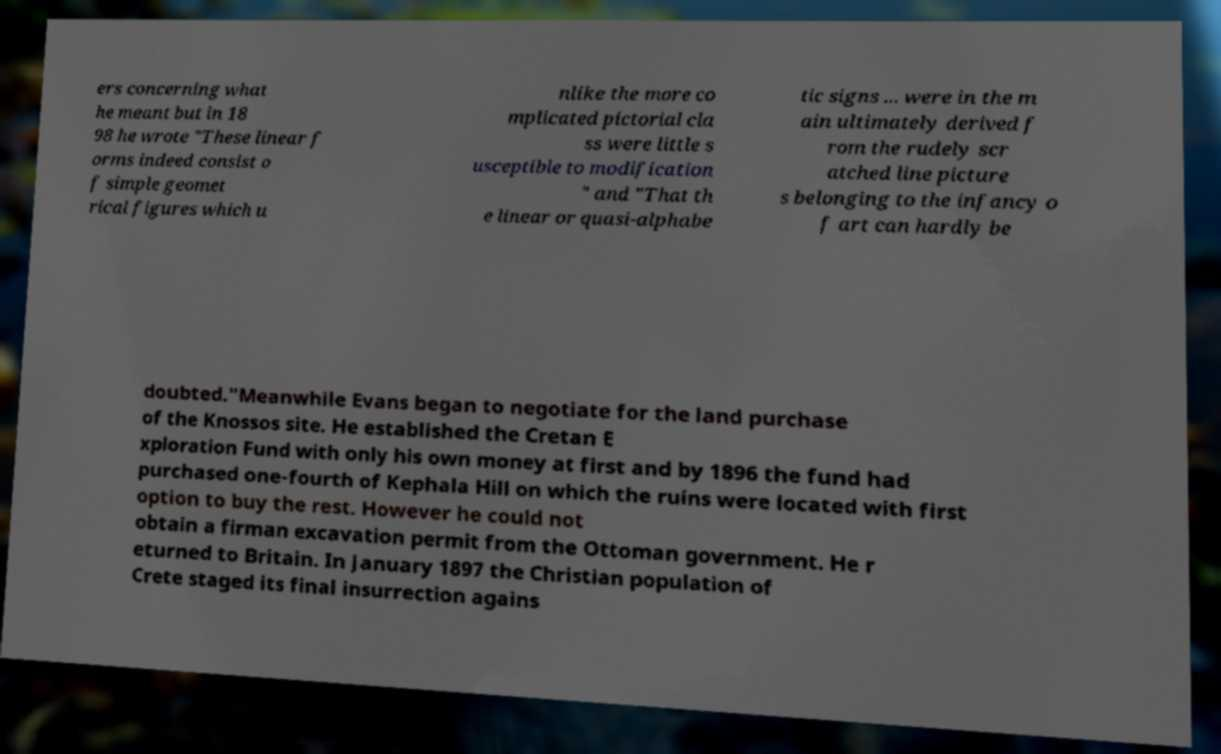There's text embedded in this image that I need extracted. Can you transcribe it verbatim? ers concerning what he meant but in 18 98 he wrote "These linear f orms indeed consist o f simple geomet rical figures which u nlike the more co mplicated pictorial cla ss were little s usceptible to modification " and "That th e linear or quasi-alphabe tic signs ... were in the m ain ultimately derived f rom the rudely scr atched line picture s belonging to the infancy o f art can hardly be doubted."Meanwhile Evans began to negotiate for the land purchase of the Knossos site. He established the Cretan E xploration Fund with only his own money at first and by 1896 the fund had purchased one-fourth of Kephala Hill on which the ruins were located with first option to buy the rest. However he could not obtain a firman excavation permit from the Ottoman government. He r eturned to Britain. In January 1897 the Christian population of Crete staged its final insurrection agains 